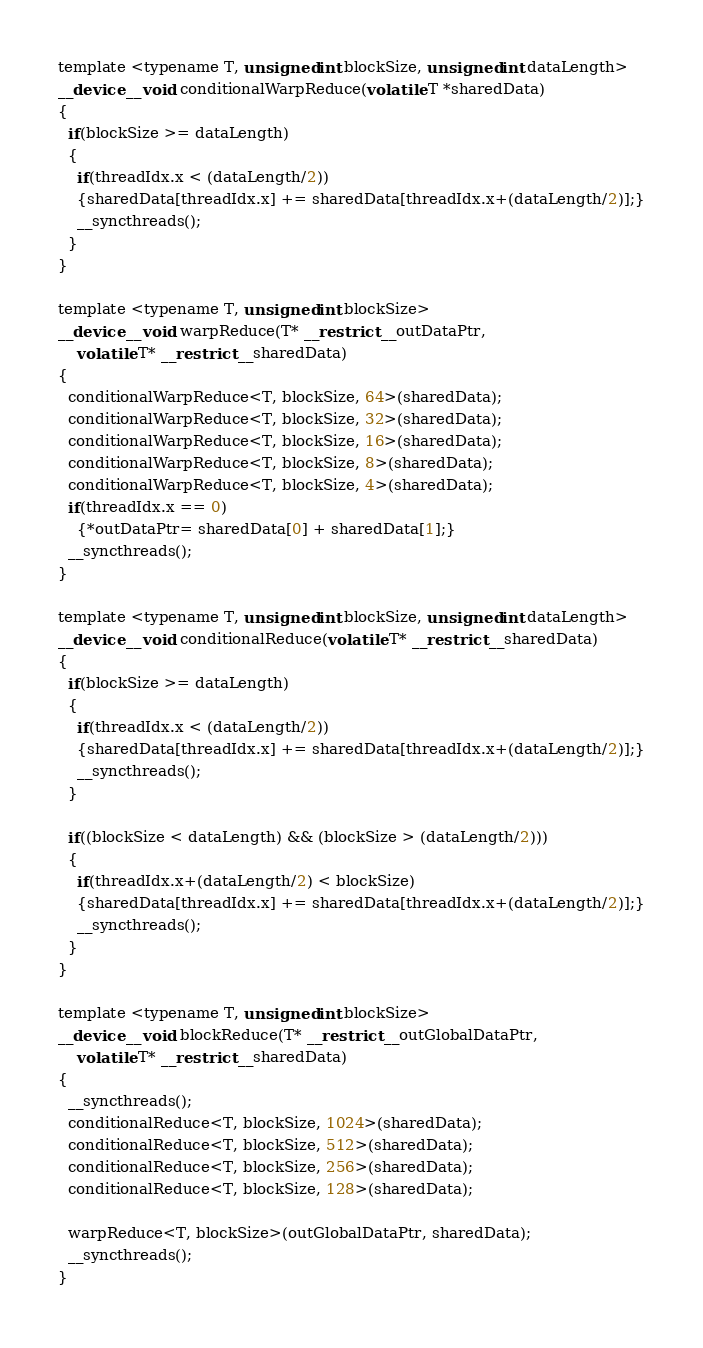Convert code to text. <code><loc_0><loc_0><loc_500><loc_500><_Cuda_>template <typename T, unsigned int blockSize, unsigned int dataLength>
__device__ void conditionalWarpReduce(volatile T *sharedData)
{
  if(blockSize >= dataLength)
  {
    if(threadIdx.x < (dataLength/2))
    {sharedData[threadIdx.x] += sharedData[threadIdx.x+(dataLength/2)];}
    __syncthreads();
  }
}

template <typename T, unsigned int blockSize>
__device__ void warpReduce(T* __restrict__ outDataPtr,
    volatile T* __restrict__ sharedData)
{
  conditionalWarpReduce<T, blockSize, 64>(sharedData);
  conditionalWarpReduce<T, blockSize, 32>(sharedData);
  conditionalWarpReduce<T, blockSize, 16>(sharedData);
  conditionalWarpReduce<T, blockSize, 8>(sharedData);
  conditionalWarpReduce<T, blockSize, 4>(sharedData);
  if(threadIdx.x == 0)
    {*outDataPtr= sharedData[0] + sharedData[1];}
  __syncthreads();
}

template <typename T, unsigned int blockSize, unsigned int dataLength>
__device__ void conditionalReduce(volatile T* __restrict__ sharedData)
{
  if(blockSize >= dataLength)
  {
    if(threadIdx.x < (dataLength/2))
    {sharedData[threadIdx.x] += sharedData[threadIdx.x+(dataLength/2)];}
    __syncthreads();
  }

  if((blockSize < dataLength) && (blockSize > (dataLength/2)))
  {
    if(threadIdx.x+(dataLength/2) < blockSize)
    {sharedData[threadIdx.x] += sharedData[threadIdx.x+(dataLength/2)];}
    __syncthreads();
  }
}

template <typename T, unsigned int blockSize>
__device__ void blockReduce(T* __restrict__ outGlobalDataPtr,
    volatile T* __restrict__ sharedData)
{
  __syncthreads();
  conditionalReduce<T, blockSize, 1024>(sharedData);
  conditionalReduce<T, blockSize, 512>(sharedData);
  conditionalReduce<T, blockSize, 256>(sharedData);
  conditionalReduce<T, blockSize, 128>(sharedData);

  warpReduce<T, blockSize>(outGlobalDataPtr, sharedData);
  __syncthreads();
}
</code> 